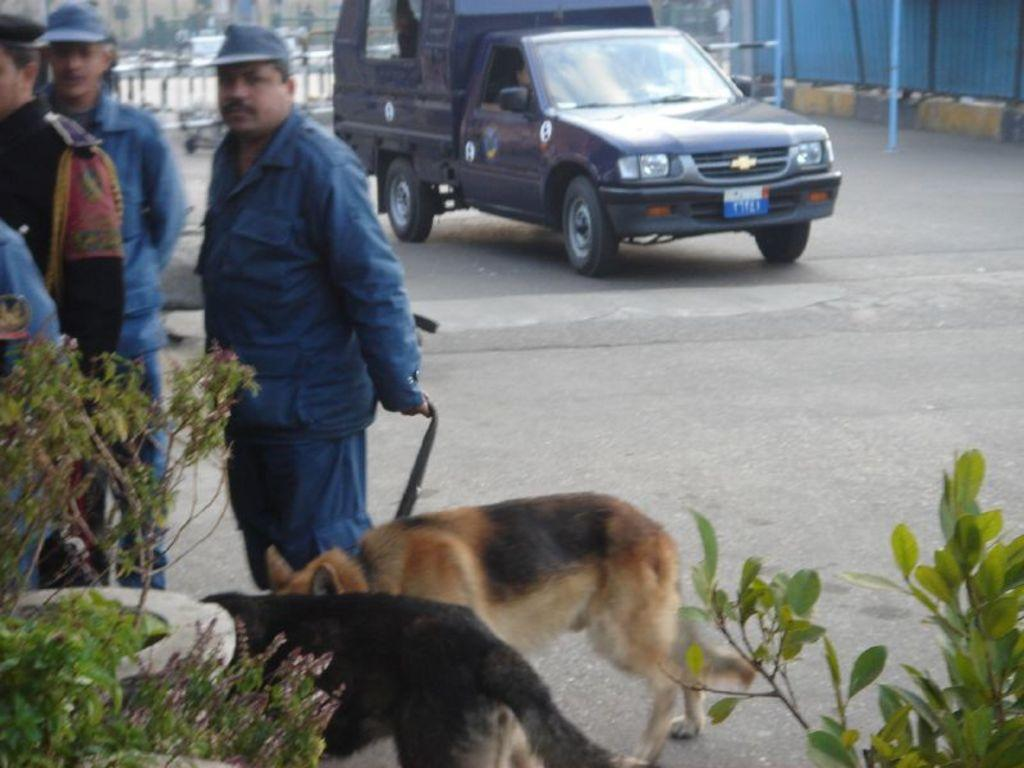How many dogs are in the image? There are two dogs in the image. How many men are in the image? There are four men in the image. What can be seen in the bottom left corner of the image? There are plants in the bottom left of the image. What can be seen in the bottom right corner of the image? There is a plant in the bottom right of the image. What is visible in the background of the image? There is a van in the background of the image. Where is the van located in the image? The van is on a road in the background of the image. What type of juice is being squeezed by the dogs in the image? There is no juice or any squeezing activity involving dogs in the image. 